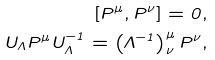Convert formula to latex. <formula><loc_0><loc_0><loc_500><loc_500>[ P ^ { \mu } , P ^ { \nu } ] = 0 , \\ U _ { \Lambda } P ^ { \mu } U _ { \Lambda } ^ { - 1 } = \left ( \Lambda ^ { - 1 } \right ) ^ { \mu } _ { \nu } P ^ { \nu } ,</formula> 